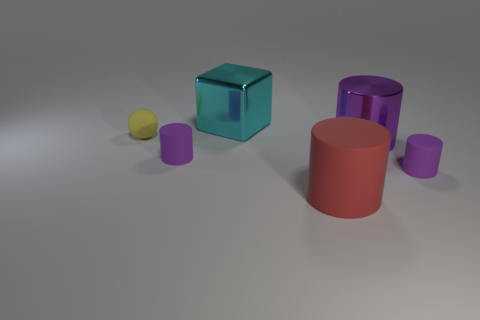How many purple cylinders must be subtracted to get 1 purple cylinders? 2 Subtract all yellow spheres. How many purple cylinders are left? 3 Subtract all gray spheres. Subtract all purple blocks. How many spheres are left? 1 Add 3 small yellow rubber things. How many objects exist? 9 Subtract all cubes. How many objects are left? 5 Add 2 big cyan metal blocks. How many big cyan metal blocks exist? 3 Subtract 0 yellow cylinders. How many objects are left? 6 Subtract all rubber balls. Subtract all large shiny cubes. How many objects are left? 4 Add 1 large metal cylinders. How many large metal cylinders are left? 2 